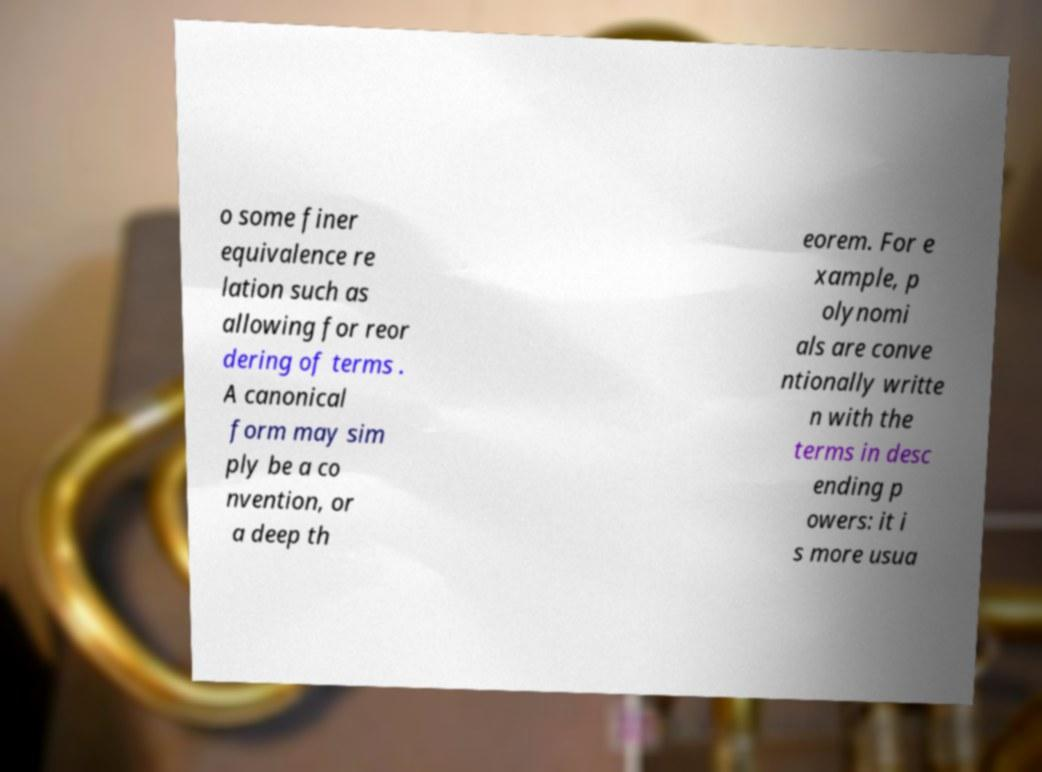Please identify and transcribe the text found in this image. o some finer equivalence re lation such as allowing for reor dering of terms . A canonical form may sim ply be a co nvention, or a deep th eorem. For e xample, p olynomi als are conve ntionally writte n with the terms in desc ending p owers: it i s more usua 